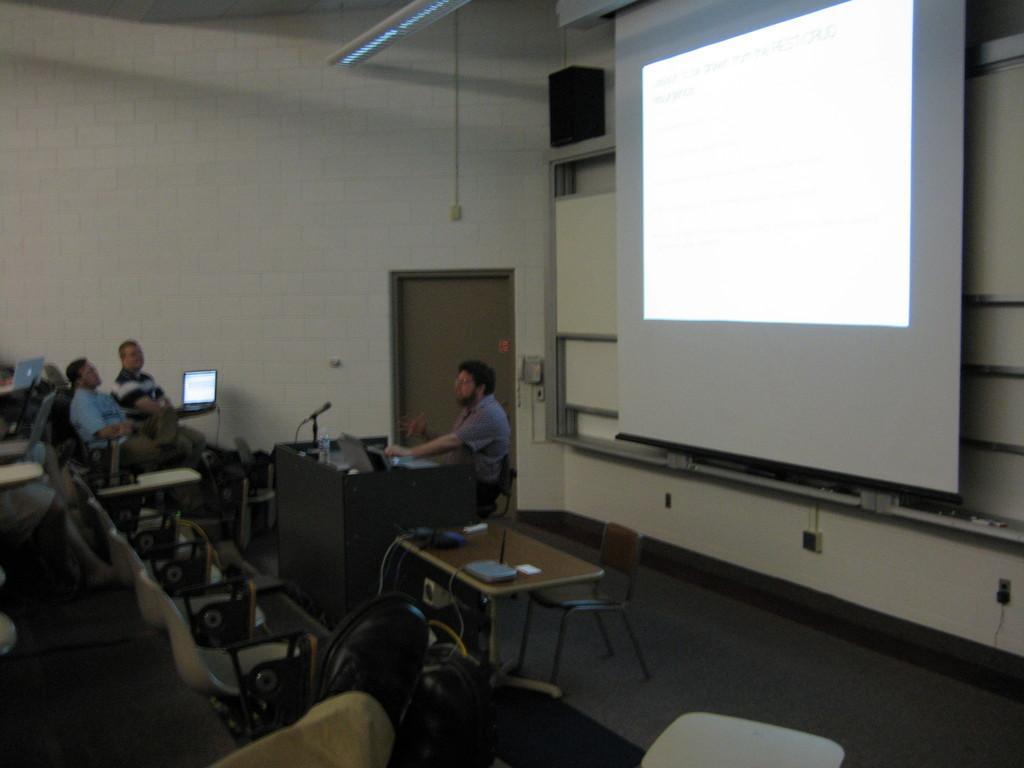How would you summarize this image in a sentence or two? As we can see in the image there is a white color wall, light, screen, chairs, tables, few people here and there and laptops. On this table there is a projector and here there is a mic. 